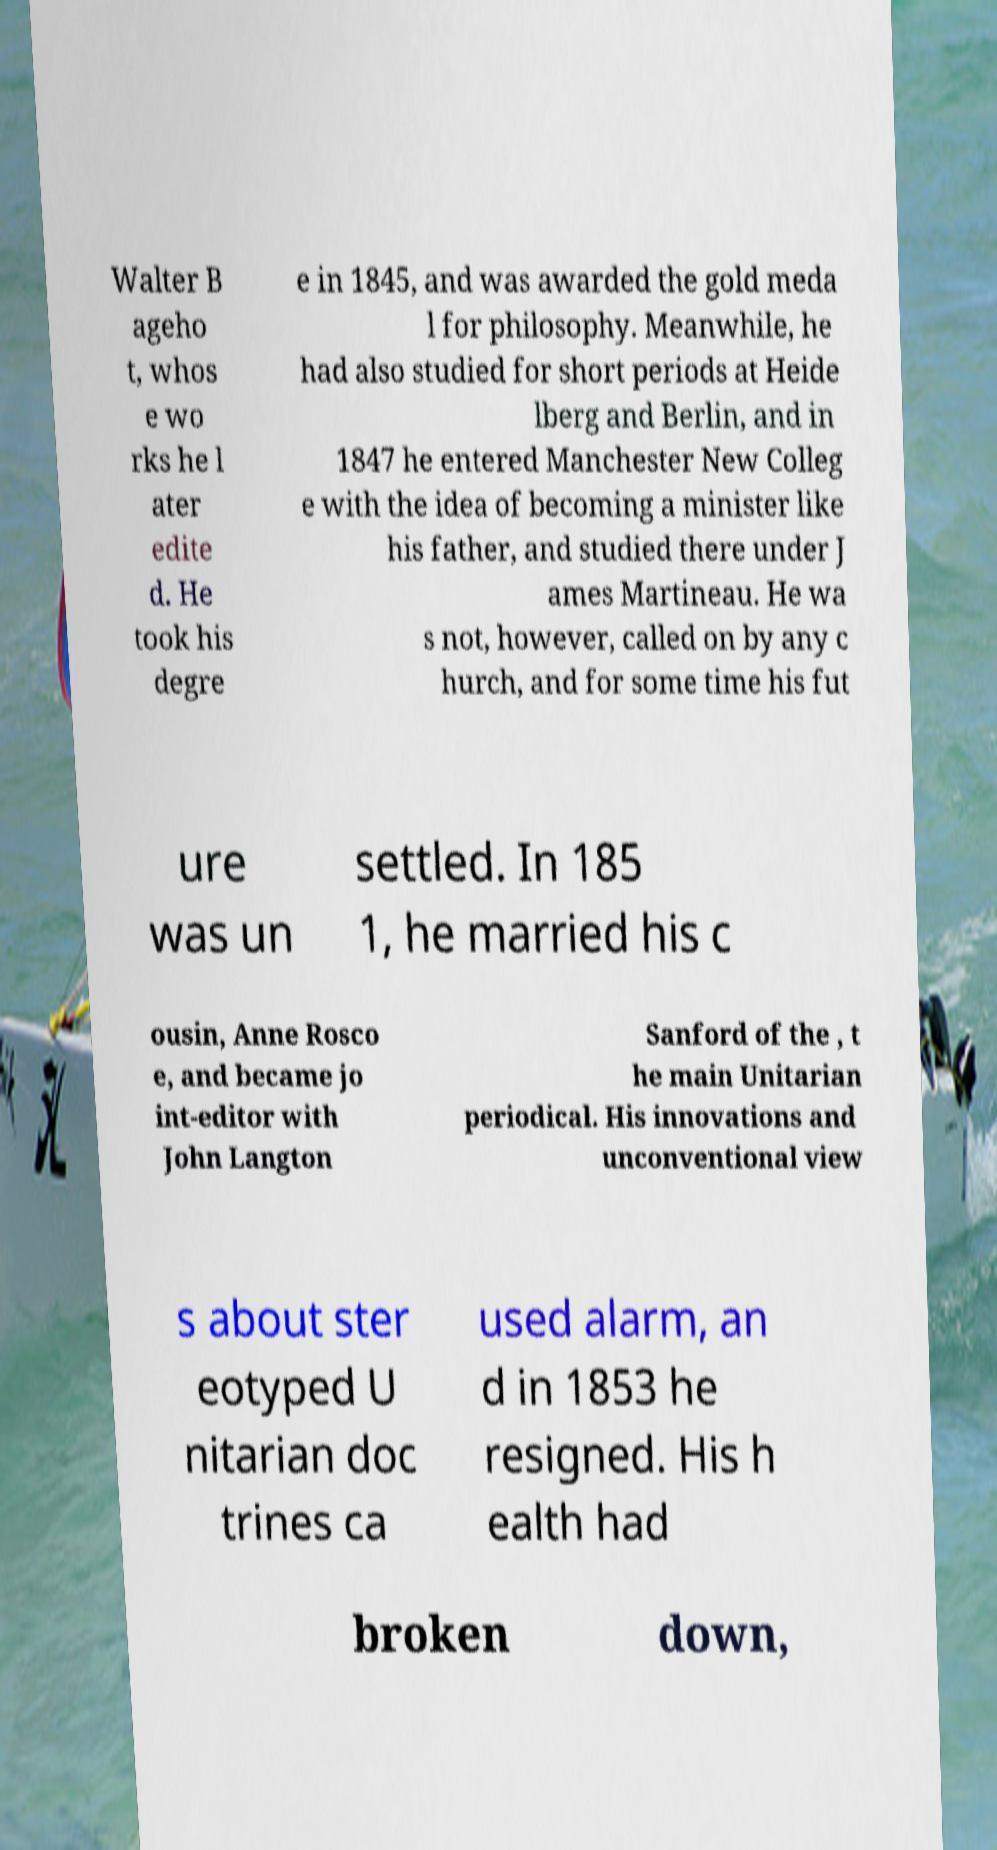Can you accurately transcribe the text from the provided image for me? Walter B ageho t, whos e wo rks he l ater edite d. He took his degre e in 1845, and was awarded the gold meda l for philosophy. Meanwhile, he had also studied for short periods at Heide lberg and Berlin, and in 1847 he entered Manchester New Colleg e with the idea of becoming a minister like his father, and studied there under J ames Martineau. He wa s not, however, called on by any c hurch, and for some time his fut ure was un settled. In 185 1, he married his c ousin, Anne Rosco e, and became jo int-editor with John Langton Sanford of the , t he main Unitarian periodical. His innovations and unconventional view s about ster eotyped U nitarian doc trines ca used alarm, an d in 1853 he resigned. His h ealth had broken down, 